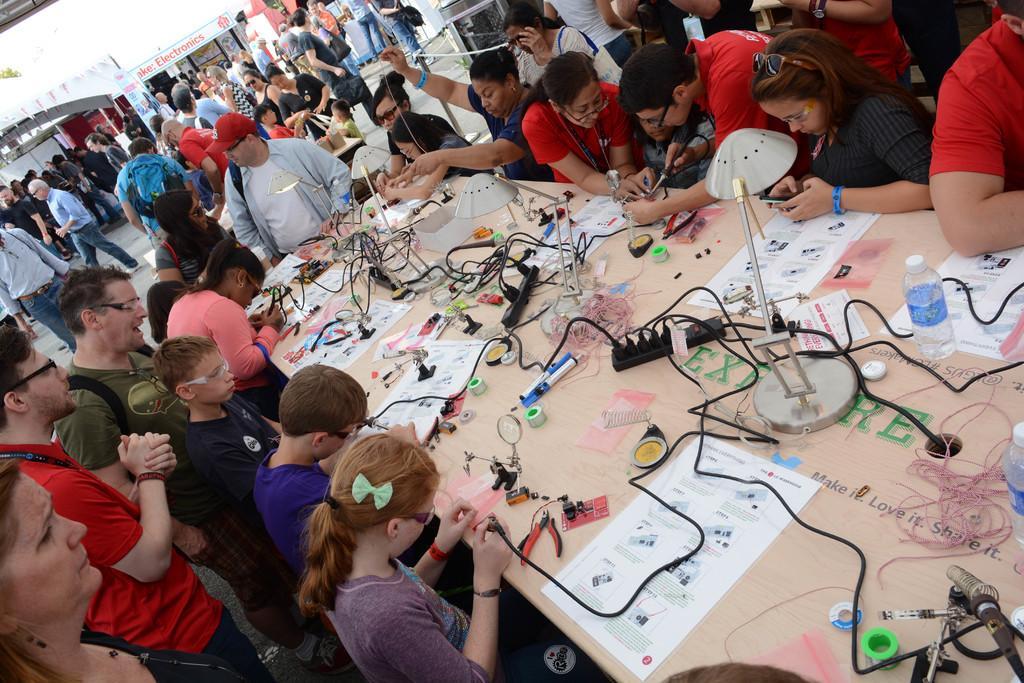Could you give a brief overview of what you see in this image? In this image we can see a table. On table wires, paper, bottle, pens, switch boards, table lights and things are present. Around the table people are sitting and standing and doing work. Background of the image so many people are present and one electronic shop is there. 